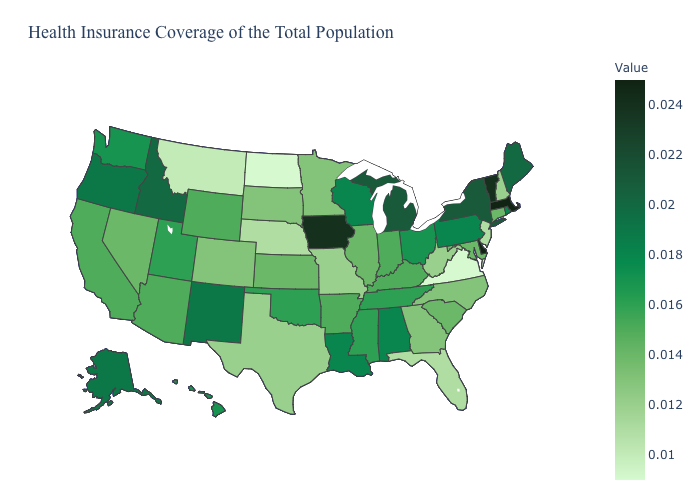Among the states that border California , which have the highest value?
Concise answer only. Oregon. Does Virginia have the lowest value in the USA?
Concise answer only. Yes. Does Oregon have a lower value than Vermont?
Answer briefly. Yes. Among the states that border Texas , does Oklahoma have the lowest value?
Quick response, please. No. 